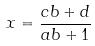Convert formula to latex. <formula><loc_0><loc_0><loc_500><loc_500>x = \frac { c b + d } { a b + 1 }</formula> 